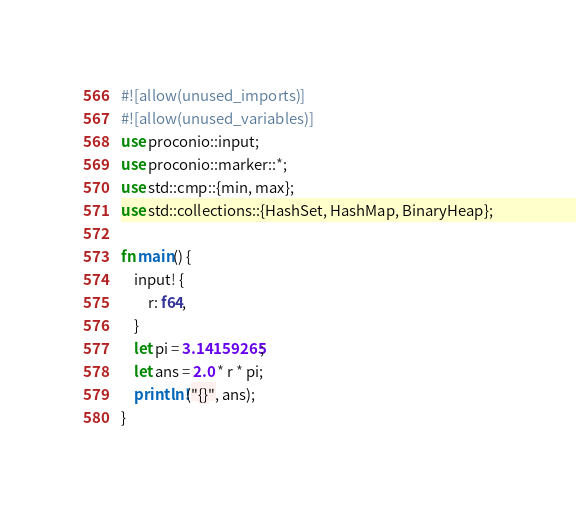Convert code to text. <code><loc_0><loc_0><loc_500><loc_500><_Rust_>#![allow(unused_imports)]
#![allow(unused_variables)]
use proconio::input;
use proconio::marker::*;
use std::cmp::{min, max};
use std::collections::{HashSet, HashMap, BinaryHeap};

fn main() {
    input! {
        r: f64,
    }
    let pi = 3.14159265;
    let ans = 2.0 * r * pi;
    println!("{}", ans);
}
</code> 